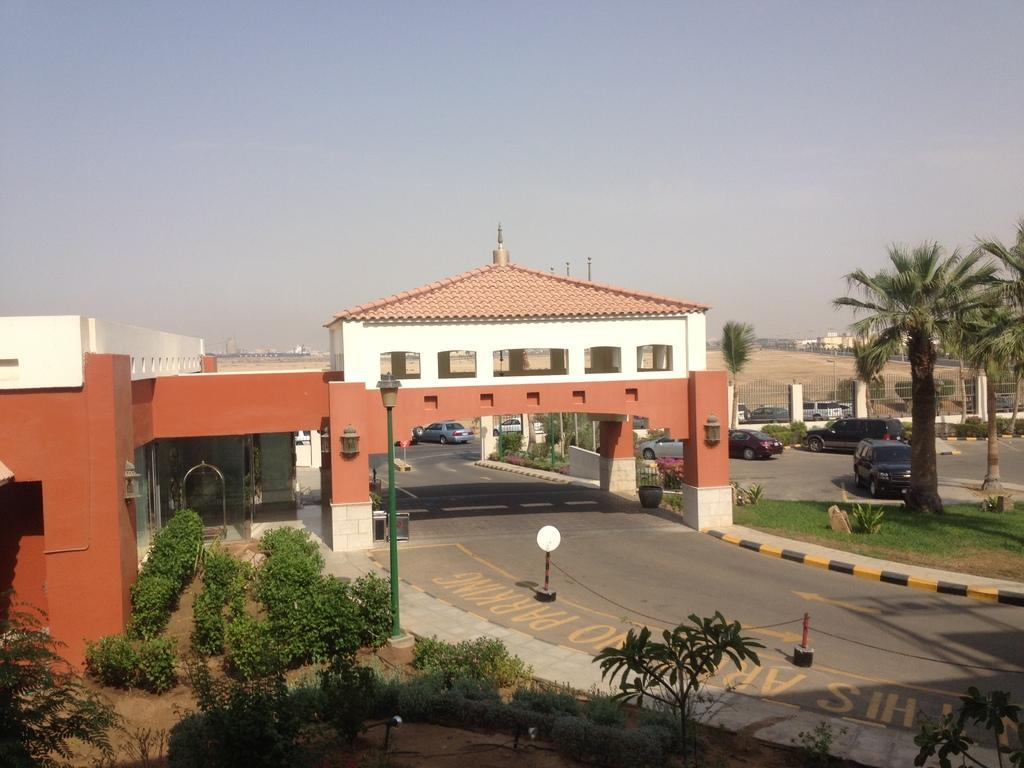What type of structures can be seen in the image? There are buildings in the image. What is the primary pathway visible in the image? There is a road in the image. What types of vehicles are present in the image? There are vehicles in the image. Can you describe the natural environment visible in the image? The ground is visible in the image, with trees, plants, and grass. What type of personnel can be seen in the image? There are police in the image. What type of illumination is present in the image? There are lights in the image. What part of the natural environment is visible in the image? The sky is visible in the image. What type of barrier is present in the image? There is fencing in the image. Where is the bottle of water located in the image? There is no bottle of water present in the image. What type of design can be seen on the cemetery in the image? There is no cemetery present in the image. 